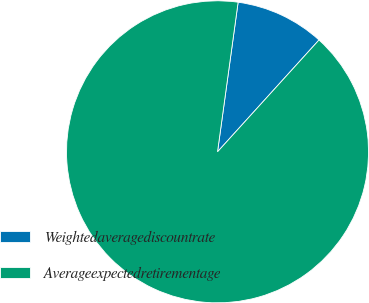<chart> <loc_0><loc_0><loc_500><loc_500><pie_chart><fcel>Weightedaveragediscountrate<fcel>Averageexpectedretirementage<nl><fcel>9.55%<fcel>90.45%<nl></chart> 